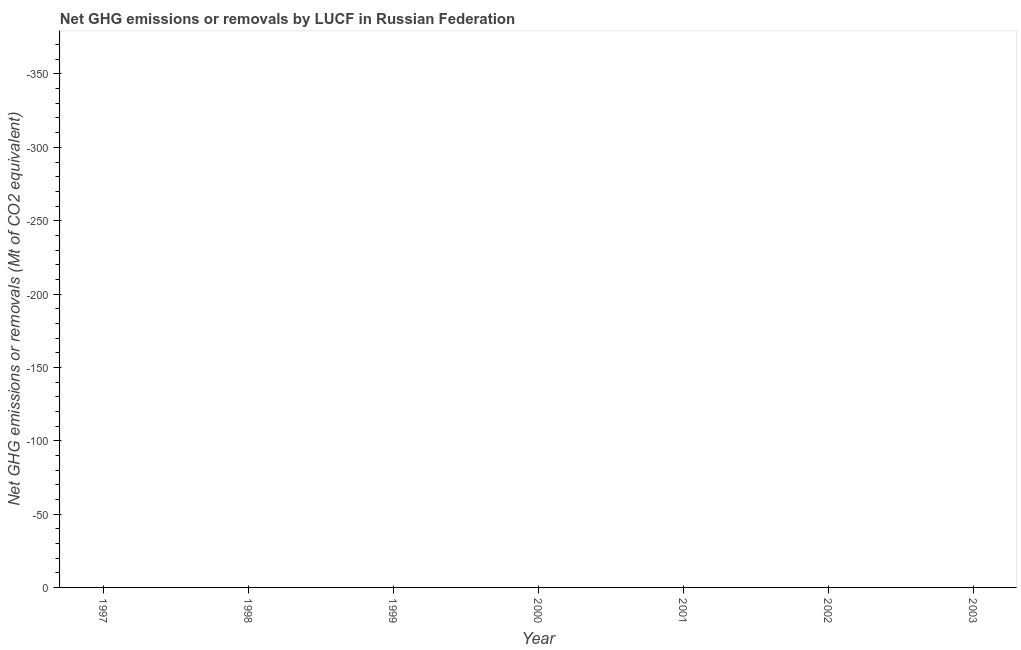Across all years, what is the minimum ghg net emissions or removals?
Ensure brevity in your answer.  0. What is the median ghg net emissions or removals?
Offer a very short reply. 0. In how many years, is the ghg net emissions or removals greater than -200 Mt?
Your answer should be compact. 0. Does the ghg net emissions or removals monotonically increase over the years?
Provide a short and direct response. No. How many years are there in the graph?
Ensure brevity in your answer.  7. What is the difference between two consecutive major ticks on the Y-axis?
Give a very brief answer. 50. Are the values on the major ticks of Y-axis written in scientific E-notation?
Offer a terse response. No. What is the title of the graph?
Make the answer very short. Net GHG emissions or removals by LUCF in Russian Federation. What is the label or title of the X-axis?
Keep it short and to the point. Year. What is the label or title of the Y-axis?
Ensure brevity in your answer.  Net GHG emissions or removals (Mt of CO2 equivalent). What is the Net GHG emissions or removals (Mt of CO2 equivalent) in 1997?
Provide a succinct answer. 0. What is the Net GHG emissions or removals (Mt of CO2 equivalent) in 1998?
Your answer should be compact. 0. What is the Net GHG emissions or removals (Mt of CO2 equivalent) in 1999?
Provide a short and direct response. 0. What is the Net GHG emissions or removals (Mt of CO2 equivalent) in 2001?
Keep it short and to the point. 0. 